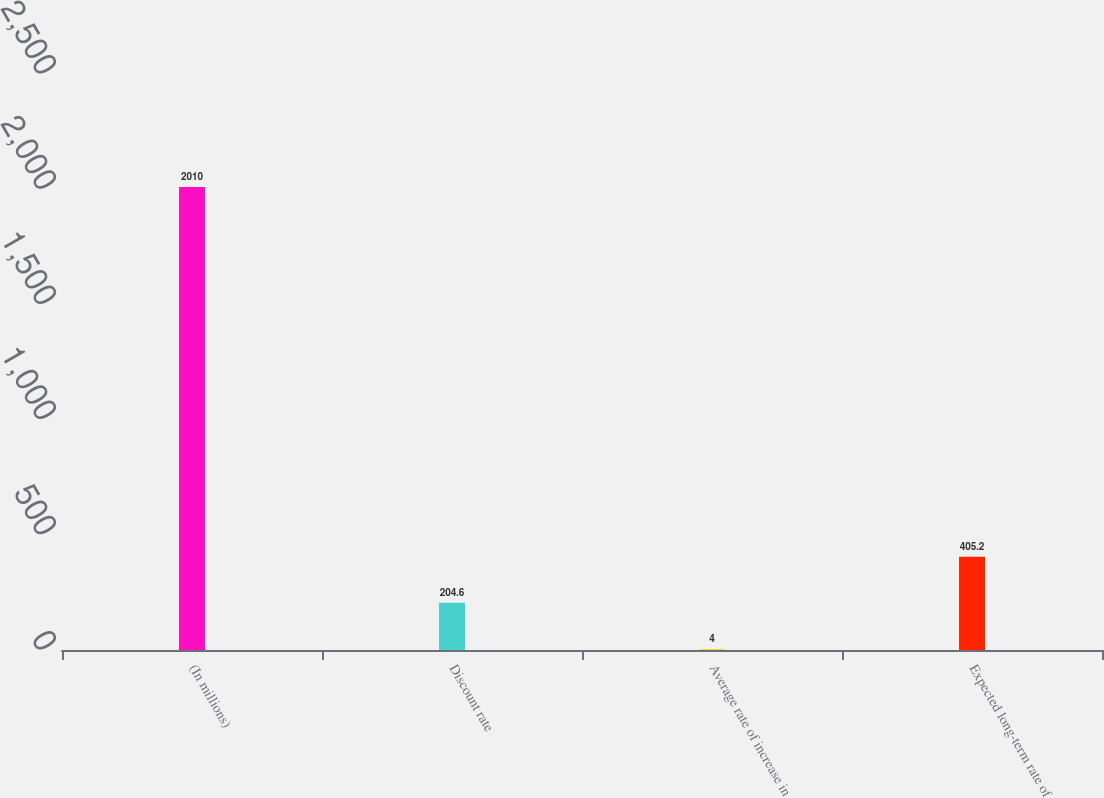Convert chart to OTSL. <chart><loc_0><loc_0><loc_500><loc_500><bar_chart><fcel>(In millions)<fcel>Discount rate<fcel>Average rate of increase in<fcel>Expected long-term rate of<nl><fcel>2010<fcel>204.6<fcel>4<fcel>405.2<nl></chart> 